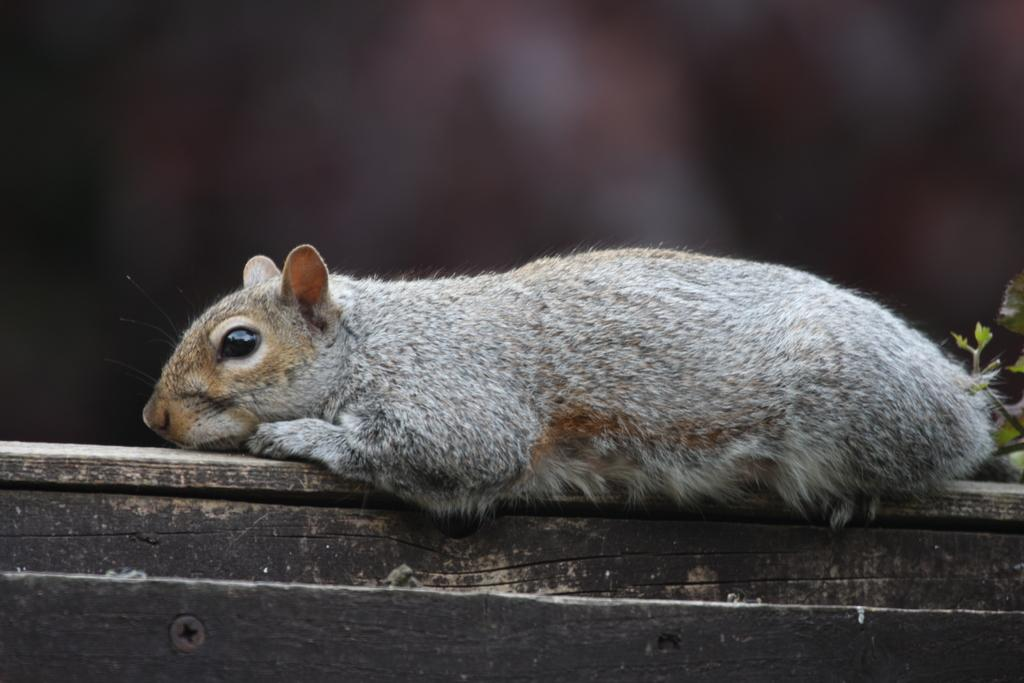What type of living creature is in the image? There is an animal in the image. What non-living object can be seen in the image? There is a wooden object in the image. What type of plant is present in the image? There is a plant in the image. What type of book is being read by the animal in the image? There is no book present in the image, and the animal is not shown reading anything. How many roses are visible in the image? There are no roses present in the image. 